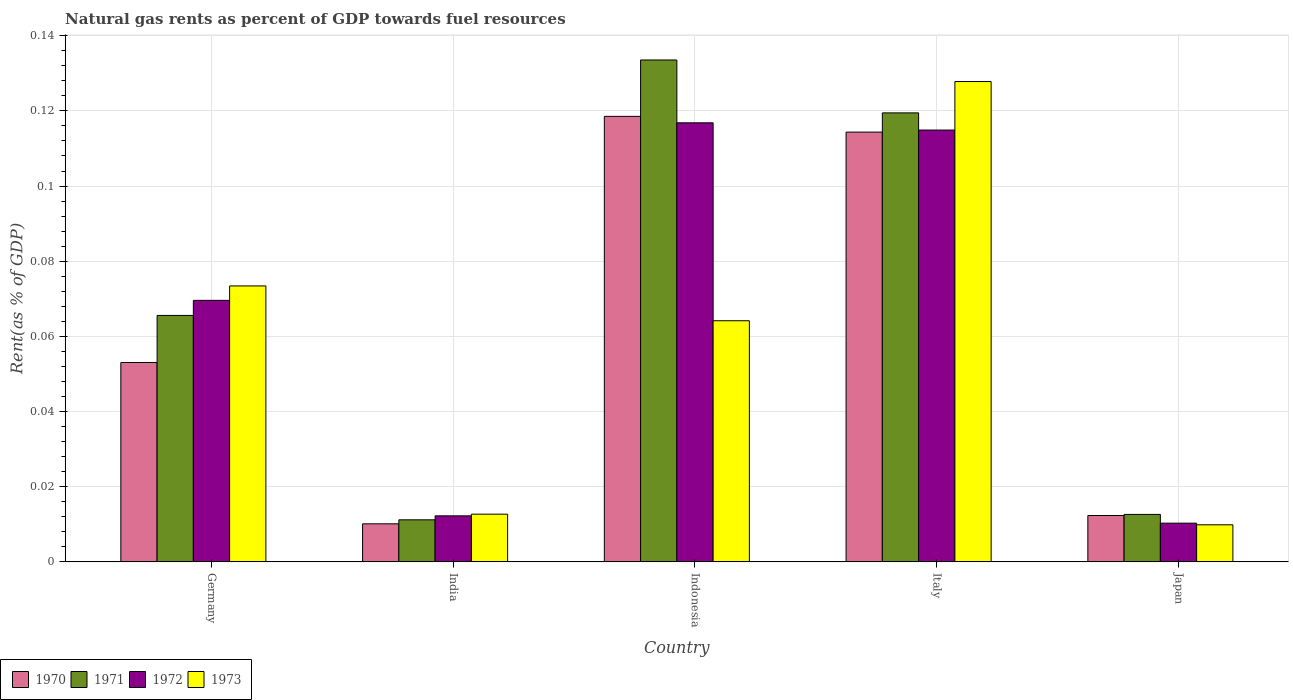How many groups of bars are there?
Provide a short and direct response. 5. Are the number of bars on each tick of the X-axis equal?
Offer a very short reply. Yes. How many bars are there on the 4th tick from the left?
Make the answer very short. 4. What is the matural gas rent in 1973 in Italy?
Offer a terse response. 0.13. Across all countries, what is the maximum matural gas rent in 1972?
Provide a succinct answer. 0.12. Across all countries, what is the minimum matural gas rent in 1971?
Provide a short and direct response. 0.01. In which country was the matural gas rent in 1970 minimum?
Your response must be concise. India. What is the total matural gas rent in 1971 in the graph?
Offer a terse response. 0.34. What is the difference between the matural gas rent in 1972 in India and that in Italy?
Ensure brevity in your answer.  -0.1. What is the difference between the matural gas rent in 1971 in India and the matural gas rent in 1970 in Germany?
Ensure brevity in your answer.  -0.04. What is the average matural gas rent in 1971 per country?
Ensure brevity in your answer.  0.07. What is the difference between the matural gas rent of/in 1971 and matural gas rent of/in 1973 in Italy?
Keep it short and to the point. -0.01. What is the ratio of the matural gas rent in 1972 in Italy to that in Japan?
Your answer should be very brief. 11.16. Is the difference between the matural gas rent in 1971 in Germany and India greater than the difference between the matural gas rent in 1973 in Germany and India?
Your response must be concise. No. What is the difference between the highest and the second highest matural gas rent in 1973?
Make the answer very short. 0.05. What is the difference between the highest and the lowest matural gas rent in 1970?
Your answer should be very brief. 0.11. In how many countries, is the matural gas rent in 1971 greater than the average matural gas rent in 1971 taken over all countries?
Ensure brevity in your answer.  2. How many bars are there?
Your response must be concise. 20. What is the difference between two consecutive major ticks on the Y-axis?
Give a very brief answer. 0.02. Are the values on the major ticks of Y-axis written in scientific E-notation?
Your answer should be compact. No. Does the graph contain any zero values?
Keep it short and to the point. No. Where does the legend appear in the graph?
Provide a succinct answer. Bottom left. How many legend labels are there?
Your answer should be very brief. 4. How are the legend labels stacked?
Keep it short and to the point. Horizontal. What is the title of the graph?
Offer a very short reply. Natural gas rents as percent of GDP towards fuel resources. Does "1974" appear as one of the legend labels in the graph?
Give a very brief answer. No. What is the label or title of the Y-axis?
Your response must be concise. Rent(as % of GDP). What is the Rent(as % of GDP) of 1970 in Germany?
Your answer should be compact. 0.05. What is the Rent(as % of GDP) of 1971 in Germany?
Your answer should be compact. 0.07. What is the Rent(as % of GDP) of 1972 in Germany?
Your response must be concise. 0.07. What is the Rent(as % of GDP) in 1973 in Germany?
Offer a very short reply. 0.07. What is the Rent(as % of GDP) in 1970 in India?
Your answer should be compact. 0.01. What is the Rent(as % of GDP) of 1971 in India?
Your answer should be very brief. 0.01. What is the Rent(as % of GDP) in 1972 in India?
Offer a very short reply. 0.01. What is the Rent(as % of GDP) of 1973 in India?
Offer a very short reply. 0.01. What is the Rent(as % of GDP) in 1970 in Indonesia?
Provide a succinct answer. 0.12. What is the Rent(as % of GDP) of 1971 in Indonesia?
Your answer should be compact. 0.13. What is the Rent(as % of GDP) of 1972 in Indonesia?
Your response must be concise. 0.12. What is the Rent(as % of GDP) of 1973 in Indonesia?
Give a very brief answer. 0.06. What is the Rent(as % of GDP) in 1970 in Italy?
Your response must be concise. 0.11. What is the Rent(as % of GDP) of 1971 in Italy?
Keep it short and to the point. 0.12. What is the Rent(as % of GDP) of 1972 in Italy?
Offer a terse response. 0.11. What is the Rent(as % of GDP) in 1973 in Italy?
Keep it short and to the point. 0.13. What is the Rent(as % of GDP) of 1970 in Japan?
Provide a short and direct response. 0.01. What is the Rent(as % of GDP) of 1971 in Japan?
Give a very brief answer. 0.01. What is the Rent(as % of GDP) in 1972 in Japan?
Offer a terse response. 0.01. What is the Rent(as % of GDP) of 1973 in Japan?
Provide a succinct answer. 0.01. Across all countries, what is the maximum Rent(as % of GDP) of 1970?
Provide a succinct answer. 0.12. Across all countries, what is the maximum Rent(as % of GDP) of 1971?
Keep it short and to the point. 0.13. Across all countries, what is the maximum Rent(as % of GDP) of 1972?
Ensure brevity in your answer.  0.12. Across all countries, what is the maximum Rent(as % of GDP) in 1973?
Ensure brevity in your answer.  0.13. Across all countries, what is the minimum Rent(as % of GDP) in 1970?
Give a very brief answer. 0.01. Across all countries, what is the minimum Rent(as % of GDP) in 1971?
Provide a succinct answer. 0.01. Across all countries, what is the minimum Rent(as % of GDP) in 1972?
Offer a terse response. 0.01. Across all countries, what is the minimum Rent(as % of GDP) of 1973?
Keep it short and to the point. 0.01. What is the total Rent(as % of GDP) of 1970 in the graph?
Your response must be concise. 0.31. What is the total Rent(as % of GDP) of 1971 in the graph?
Provide a short and direct response. 0.34. What is the total Rent(as % of GDP) in 1972 in the graph?
Your answer should be compact. 0.32. What is the total Rent(as % of GDP) in 1973 in the graph?
Keep it short and to the point. 0.29. What is the difference between the Rent(as % of GDP) of 1970 in Germany and that in India?
Your answer should be compact. 0.04. What is the difference between the Rent(as % of GDP) of 1971 in Germany and that in India?
Your answer should be very brief. 0.05. What is the difference between the Rent(as % of GDP) in 1972 in Germany and that in India?
Your response must be concise. 0.06. What is the difference between the Rent(as % of GDP) in 1973 in Germany and that in India?
Give a very brief answer. 0.06. What is the difference between the Rent(as % of GDP) in 1970 in Germany and that in Indonesia?
Offer a terse response. -0.07. What is the difference between the Rent(as % of GDP) in 1971 in Germany and that in Indonesia?
Your answer should be very brief. -0.07. What is the difference between the Rent(as % of GDP) in 1972 in Germany and that in Indonesia?
Offer a terse response. -0.05. What is the difference between the Rent(as % of GDP) of 1973 in Germany and that in Indonesia?
Your response must be concise. 0.01. What is the difference between the Rent(as % of GDP) of 1970 in Germany and that in Italy?
Make the answer very short. -0.06. What is the difference between the Rent(as % of GDP) in 1971 in Germany and that in Italy?
Your answer should be compact. -0.05. What is the difference between the Rent(as % of GDP) of 1972 in Germany and that in Italy?
Make the answer very short. -0.05. What is the difference between the Rent(as % of GDP) of 1973 in Germany and that in Italy?
Give a very brief answer. -0.05. What is the difference between the Rent(as % of GDP) in 1970 in Germany and that in Japan?
Ensure brevity in your answer.  0.04. What is the difference between the Rent(as % of GDP) in 1971 in Germany and that in Japan?
Make the answer very short. 0.05. What is the difference between the Rent(as % of GDP) of 1972 in Germany and that in Japan?
Your response must be concise. 0.06. What is the difference between the Rent(as % of GDP) of 1973 in Germany and that in Japan?
Ensure brevity in your answer.  0.06. What is the difference between the Rent(as % of GDP) in 1970 in India and that in Indonesia?
Ensure brevity in your answer.  -0.11. What is the difference between the Rent(as % of GDP) of 1971 in India and that in Indonesia?
Offer a terse response. -0.12. What is the difference between the Rent(as % of GDP) of 1972 in India and that in Indonesia?
Provide a succinct answer. -0.1. What is the difference between the Rent(as % of GDP) of 1973 in India and that in Indonesia?
Your answer should be compact. -0.05. What is the difference between the Rent(as % of GDP) of 1970 in India and that in Italy?
Give a very brief answer. -0.1. What is the difference between the Rent(as % of GDP) in 1971 in India and that in Italy?
Provide a short and direct response. -0.11. What is the difference between the Rent(as % of GDP) in 1972 in India and that in Italy?
Provide a succinct answer. -0.1. What is the difference between the Rent(as % of GDP) in 1973 in India and that in Italy?
Your answer should be very brief. -0.12. What is the difference between the Rent(as % of GDP) of 1970 in India and that in Japan?
Your answer should be very brief. -0. What is the difference between the Rent(as % of GDP) in 1971 in India and that in Japan?
Keep it short and to the point. -0. What is the difference between the Rent(as % of GDP) of 1972 in India and that in Japan?
Offer a terse response. 0. What is the difference between the Rent(as % of GDP) in 1973 in India and that in Japan?
Offer a terse response. 0. What is the difference between the Rent(as % of GDP) in 1970 in Indonesia and that in Italy?
Provide a short and direct response. 0. What is the difference between the Rent(as % of GDP) of 1971 in Indonesia and that in Italy?
Your response must be concise. 0.01. What is the difference between the Rent(as % of GDP) in 1972 in Indonesia and that in Italy?
Your response must be concise. 0. What is the difference between the Rent(as % of GDP) in 1973 in Indonesia and that in Italy?
Your response must be concise. -0.06. What is the difference between the Rent(as % of GDP) in 1970 in Indonesia and that in Japan?
Provide a succinct answer. 0.11. What is the difference between the Rent(as % of GDP) of 1971 in Indonesia and that in Japan?
Provide a succinct answer. 0.12. What is the difference between the Rent(as % of GDP) in 1972 in Indonesia and that in Japan?
Make the answer very short. 0.11. What is the difference between the Rent(as % of GDP) of 1973 in Indonesia and that in Japan?
Make the answer very short. 0.05. What is the difference between the Rent(as % of GDP) in 1970 in Italy and that in Japan?
Ensure brevity in your answer.  0.1. What is the difference between the Rent(as % of GDP) of 1971 in Italy and that in Japan?
Your answer should be compact. 0.11. What is the difference between the Rent(as % of GDP) of 1972 in Italy and that in Japan?
Offer a terse response. 0.1. What is the difference between the Rent(as % of GDP) of 1973 in Italy and that in Japan?
Make the answer very short. 0.12. What is the difference between the Rent(as % of GDP) of 1970 in Germany and the Rent(as % of GDP) of 1971 in India?
Ensure brevity in your answer.  0.04. What is the difference between the Rent(as % of GDP) of 1970 in Germany and the Rent(as % of GDP) of 1972 in India?
Your answer should be compact. 0.04. What is the difference between the Rent(as % of GDP) in 1970 in Germany and the Rent(as % of GDP) in 1973 in India?
Your answer should be very brief. 0.04. What is the difference between the Rent(as % of GDP) in 1971 in Germany and the Rent(as % of GDP) in 1972 in India?
Offer a terse response. 0.05. What is the difference between the Rent(as % of GDP) in 1971 in Germany and the Rent(as % of GDP) in 1973 in India?
Offer a very short reply. 0.05. What is the difference between the Rent(as % of GDP) of 1972 in Germany and the Rent(as % of GDP) of 1973 in India?
Offer a very short reply. 0.06. What is the difference between the Rent(as % of GDP) of 1970 in Germany and the Rent(as % of GDP) of 1971 in Indonesia?
Offer a terse response. -0.08. What is the difference between the Rent(as % of GDP) of 1970 in Germany and the Rent(as % of GDP) of 1972 in Indonesia?
Offer a terse response. -0.06. What is the difference between the Rent(as % of GDP) in 1970 in Germany and the Rent(as % of GDP) in 1973 in Indonesia?
Give a very brief answer. -0.01. What is the difference between the Rent(as % of GDP) of 1971 in Germany and the Rent(as % of GDP) of 1972 in Indonesia?
Offer a terse response. -0.05. What is the difference between the Rent(as % of GDP) of 1971 in Germany and the Rent(as % of GDP) of 1973 in Indonesia?
Offer a very short reply. 0. What is the difference between the Rent(as % of GDP) of 1972 in Germany and the Rent(as % of GDP) of 1973 in Indonesia?
Provide a short and direct response. 0.01. What is the difference between the Rent(as % of GDP) in 1970 in Germany and the Rent(as % of GDP) in 1971 in Italy?
Your answer should be compact. -0.07. What is the difference between the Rent(as % of GDP) of 1970 in Germany and the Rent(as % of GDP) of 1972 in Italy?
Give a very brief answer. -0.06. What is the difference between the Rent(as % of GDP) of 1970 in Germany and the Rent(as % of GDP) of 1973 in Italy?
Your response must be concise. -0.07. What is the difference between the Rent(as % of GDP) of 1971 in Germany and the Rent(as % of GDP) of 1972 in Italy?
Ensure brevity in your answer.  -0.05. What is the difference between the Rent(as % of GDP) in 1971 in Germany and the Rent(as % of GDP) in 1973 in Italy?
Your answer should be compact. -0.06. What is the difference between the Rent(as % of GDP) in 1972 in Germany and the Rent(as % of GDP) in 1973 in Italy?
Your response must be concise. -0.06. What is the difference between the Rent(as % of GDP) in 1970 in Germany and the Rent(as % of GDP) in 1971 in Japan?
Give a very brief answer. 0.04. What is the difference between the Rent(as % of GDP) in 1970 in Germany and the Rent(as % of GDP) in 1972 in Japan?
Your answer should be very brief. 0.04. What is the difference between the Rent(as % of GDP) in 1970 in Germany and the Rent(as % of GDP) in 1973 in Japan?
Your response must be concise. 0.04. What is the difference between the Rent(as % of GDP) in 1971 in Germany and the Rent(as % of GDP) in 1972 in Japan?
Provide a succinct answer. 0.06. What is the difference between the Rent(as % of GDP) of 1971 in Germany and the Rent(as % of GDP) of 1973 in Japan?
Your answer should be very brief. 0.06. What is the difference between the Rent(as % of GDP) of 1972 in Germany and the Rent(as % of GDP) of 1973 in Japan?
Give a very brief answer. 0.06. What is the difference between the Rent(as % of GDP) in 1970 in India and the Rent(as % of GDP) in 1971 in Indonesia?
Your answer should be compact. -0.12. What is the difference between the Rent(as % of GDP) of 1970 in India and the Rent(as % of GDP) of 1972 in Indonesia?
Ensure brevity in your answer.  -0.11. What is the difference between the Rent(as % of GDP) of 1970 in India and the Rent(as % of GDP) of 1973 in Indonesia?
Ensure brevity in your answer.  -0.05. What is the difference between the Rent(as % of GDP) of 1971 in India and the Rent(as % of GDP) of 1972 in Indonesia?
Offer a terse response. -0.11. What is the difference between the Rent(as % of GDP) of 1971 in India and the Rent(as % of GDP) of 1973 in Indonesia?
Your response must be concise. -0.05. What is the difference between the Rent(as % of GDP) of 1972 in India and the Rent(as % of GDP) of 1973 in Indonesia?
Your answer should be compact. -0.05. What is the difference between the Rent(as % of GDP) of 1970 in India and the Rent(as % of GDP) of 1971 in Italy?
Keep it short and to the point. -0.11. What is the difference between the Rent(as % of GDP) of 1970 in India and the Rent(as % of GDP) of 1972 in Italy?
Provide a succinct answer. -0.1. What is the difference between the Rent(as % of GDP) of 1970 in India and the Rent(as % of GDP) of 1973 in Italy?
Ensure brevity in your answer.  -0.12. What is the difference between the Rent(as % of GDP) of 1971 in India and the Rent(as % of GDP) of 1972 in Italy?
Provide a succinct answer. -0.1. What is the difference between the Rent(as % of GDP) of 1971 in India and the Rent(as % of GDP) of 1973 in Italy?
Keep it short and to the point. -0.12. What is the difference between the Rent(as % of GDP) of 1972 in India and the Rent(as % of GDP) of 1973 in Italy?
Give a very brief answer. -0.12. What is the difference between the Rent(as % of GDP) in 1970 in India and the Rent(as % of GDP) in 1971 in Japan?
Provide a short and direct response. -0. What is the difference between the Rent(as % of GDP) in 1970 in India and the Rent(as % of GDP) in 1972 in Japan?
Provide a short and direct response. -0. What is the difference between the Rent(as % of GDP) in 1971 in India and the Rent(as % of GDP) in 1972 in Japan?
Keep it short and to the point. 0. What is the difference between the Rent(as % of GDP) of 1971 in India and the Rent(as % of GDP) of 1973 in Japan?
Offer a terse response. 0. What is the difference between the Rent(as % of GDP) in 1972 in India and the Rent(as % of GDP) in 1973 in Japan?
Your answer should be very brief. 0. What is the difference between the Rent(as % of GDP) in 1970 in Indonesia and the Rent(as % of GDP) in 1971 in Italy?
Your response must be concise. -0. What is the difference between the Rent(as % of GDP) in 1970 in Indonesia and the Rent(as % of GDP) in 1972 in Italy?
Make the answer very short. 0. What is the difference between the Rent(as % of GDP) in 1970 in Indonesia and the Rent(as % of GDP) in 1973 in Italy?
Provide a succinct answer. -0.01. What is the difference between the Rent(as % of GDP) in 1971 in Indonesia and the Rent(as % of GDP) in 1972 in Italy?
Your answer should be compact. 0.02. What is the difference between the Rent(as % of GDP) in 1971 in Indonesia and the Rent(as % of GDP) in 1973 in Italy?
Offer a terse response. 0.01. What is the difference between the Rent(as % of GDP) of 1972 in Indonesia and the Rent(as % of GDP) of 1973 in Italy?
Your answer should be very brief. -0.01. What is the difference between the Rent(as % of GDP) in 1970 in Indonesia and the Rent(as % of GDP) in 1971 in Japan?
Ensure brevity in your answer.  0.11. What is the difference between the Rent(as % of GDP) of 1970 in Indonesia and the Rent(as % of GDP) of 1972 in Japan?
Your response must be concise. 0.11. What is the difference between the Rent(as % of GDP) in 1970 in Indonesia and the Rent(as % of GDP) in 1973 in Japan?
Ensure brevity in your answer.  0.11. What is the difference between the Rent(as % of GDP) of 1971 in Indonesia and the Rent(as % of GDP) of 1972 in Japan?
Give a very brief answer. 0.12. What is the difference between the Rent(as % of GDP) of 1971 in Indonesia and the Rent(as % of GDP) of 1973 in Japan?
Keep it short and to the point. 0.12. What is the difference between the Rent(as % of GDP) of 1972 in Indonesia and the Rent(as % of GDP) of 1973 in Japan?
Offer a very short reply. 0.11. What is the difference between the Rent(as % of GDP) in 1970 in Italy and the Rent(as % of GDP) in 1971 in Japan?
Provide a succinct answer. 0.1. What is the difference between the Rent(as % of GDP) in 1970 in Italy and the Rent(as % of GDP) in 1972 in Japan?
Provide a short and direct response. 0.1. What is the difference between the Rent(as % of GDP) of 1970 in Italy and the Rent(as % of GDP) of 1973 in Japan?
Provide a succinct answer. 0.1. What is the difference between the Rent(as % of GDP) of 1971 in Italy and the Rent(as % of GDP) of 1972 in Japan?
Your response must be concise. 0.11. What is the difference between the Rent(as % of GDP) in 1971 in Italy and the Rent(as % of GDP) in 1973 in Japan?
Provide a succinct answer. 0.11. What is the difference between the Rent(as % of GDP) in 1972 in Italy and the Rent(as % of GDP) in 1973 in Japan?
Provide a short and direct response. 0.1. What is the average Rent(as % of GDP) of 1970 per country?
Your answer should be very brief. 0.06. What is the average Rent(as % of GDP) of 1971 per country?
Provide a short and direct response. 0.07. What is the average Rent(as % of GDP) of 1972 per country?
Offer a very short reply. 0.06. What is the average Rent(as % of GDP) of 1973 per country?
Give a very brief answer. 0.06. What is the difference between the Rent(as % of GDP) of 1970 and Rent(as % of GDP) of 1971 in Germany?
Make the answer very short. -0.01. What is the difference between the Rent(as % of GDP) in 1970 and Rent(as % of GDP) in 1972 in Germany?
Provide a short and direct response. -0.02. What is the difference between the Rent(as % of GDP) of 1970 and Rent(as % of GDP) of 1973 in Germany?
Give a very brief answer. -0.02. What is the difference between the Rent(as % of GDP) in 1971 and Rent(as % of GDP) in 1972 in Germany?
Your answer should be compact. -0. What is the difference between the Rent(as % of GDP) of 1971 and Rent(as % of GDP) of 1973 in Germany?
Your answer should be very brief. -0.01. What is the difference between the Rent(as % of GDP) in 1972 and Rent(as % of GDP) in 1973 in Germany?
Provide a short and direct response. -0. What is the difference between the Rent(as % of GDP) in 1970 and Rent(as % of GDP) in 1971 in India?
Keep it short and to the point. -0. What is the difference between the Rent(as % of GDP) in 1970 and Rent(as % of GDP) in 1972 in India?
Provide a succinct answer. -0. What is the difference between the Rent(as % of GDP) of 1970 and Rent(as % of GDP) of 1973 in India?
Your answer should be very brief. -0. What is the difference between the Rent(as % of GDP) of 1971 and Rent(as % of GDP) of 1972 in India?
Keep it short and to the point. -0. What is the difference between the Rent(as % of GDP) in 1971 and Rent(as % of GDP) in 1973 in India?
Provide a short and direct response. -0. What is the difference between the Rent(as % of GDP) of 1972 and Rent(as % of GDP) of 1973 in India?
Ensure brevity in your answer.  -0. What is the difference between the Rent(as % of GDP) in 1970 and Rent(as % of GDP) in 1971 in Indonesia?
Your response must be concise. -0.01. What is the difference between the Rent(as % of GDP) of 1970 and Rent(as % of GDP) of 1972 in Indonesia?
Keep it short and to the point. 0. What is the difference between the Rent(as % of GDP) of 1970 and Rent(as % of GDP) of 1973 in Indonesia?
Give a very brief answer. 0.05. What is the difference between the Rent(as % of GDP) in 1971 and Rent(as % of GDP) in 1972 in Indonesia?
Offer a very short reply. 0.02. What is the difference between the Rent(as % of GDP) of 1971 and Rent(as % of GDP) of 1973 in Indonesia?
Provide a succinct answer. 0.07. What is the difference between the Rent(as % of GDP) of 1972 and Rent(as % of GDP) of 1973 in Indonesia?
Provide a short and direct response. 0.05. What is the difference between the Rent(as % of GDP) of 1970 and Rent(as % of GDP) of 1971 in Italy?
Provide a succinct answer. -0.01. What is the difference between the Rent(as % of GDP) of 1970 and Rent(as % of GDP) of 1972 in Italy?
Provide a short and direct response. -0. What is the difference between the Rent(as % of GDP) of 1970 and Rent(as % of GDP) of 1973 in Italy?
Provide a short and direct response. -0.01. What is the difference between the Rent(as % of GDP) in 1971 and Rent(as % of GDP) in 1972 in Italy?
Your answer should be very brief. 0. What is the difference between the Rent(as % of GDP) of 1971 and Rent(as % of GDP) of 1973 in Italy?
Your answer should be compact. -0.01. What is the difference between the Rent(as % of GDP) of 1972 and Rent(as % of GDP) of 1973 in Italy?
Your answer should be compact. -0.01. What is the difference between the Rent(as % of GDP) of 1970 and Rent(as % of GDP) of 1971 in Japan?
Provide a succinct answer. -0. What is the difference between the Rent(as % of GDP) in 1970 and Rent(as % of GDP) in 1972 in Japan?
Make the answer very short. 0. What is the difference between the Rent(as % of GDP) in 1970 and Rent(as % of GDP) in 1973 in Japan?
Your answer should be compact. 0. What is the difference between the Rent(as % of GDP) of 1971 and Rent(as % of GDP) of 1972 in Japan?
Your answer should be very brief. 0. What is the difference between the Rent(as % of GDP) of 1971 and Rent(as % of GDP) of 1973 in Japan?
Provide a short and direct response. 0. What is the ratio of the Rent(as % of GDP) in 1970 in Germany to that in India?
Your response must be concise. 5.24. What is the ratio of the Rent(as % of GDP) of 1971 in Germany to that in India?
Give a very brief answer. 5.86. What is the ratio of the Rent(as % of GDP) in 1972 in Germany to that in India?
Make the answer very short. 5.68. What is the ratio of the Rent(as % of GDP) of 1973 in Germany to that in India?
Provide a succinct answer. 5.79. What is the ratio of the Rent(as % of GDP) of 1970 in Germany to that in Indonesia?
Offer a terse response. 0.45. What is the ratio of the Rent(as % of GDP) of 1971 in Germany to that in Indonesia?
Your response must be concise. 0.49. What is the ratio of the Rent(as % of GDP) of 1972 in Germany to that in Indonesia?
Make the answer very short. 0.6. What is the ratio of the Rent(as % of GDP) of 1973 in Germany to that in Indonesia?
Provide a succinct answer. 1.14. What is the ratio of the Rent(as % of GDP) of 1970 in Germany to that in Italy?
Provide a short and direct response. 0.46. What is the ratio of the Rent(as % of GDP) of 1971 in Germany to that in Italy?
Give a very brief answer. 0.55. What is the ratio of the Rent(as % of GDP) in 1972 in Germany to that in Italy?
Make the answer very short. 0.61. What is the ratio of the Rent(as % of GDP) in 1973 in Germany to that in Italy?
Your answer should be compact. 0.57. What is the ratio of the Rent(as % of GDP) in 1970 in Germany to that in Japan?
Keep it short and to the point. 4.3. What is the ratio of the Rent(as % of GDP) of 1971 in Germany to that in Japan?
Offer a terse response. 5.19. What is the ratio of the Rent(as % of GDP) in 1972 in Germany to that in Japan?
Your answer should be compact. 6.76. What is the ratio of the Rent(as % of GDP) of 1973 in Germany to that in Japan?
Keep it short and to the point. 7.44. What is the ratio of the Rent(as % of GDP) of 1970 in India to that in Indonesia?
Your answer should be very brief. 0.09. What is the ratio of the Rent(as % of GDP) of 1971 in India to that in Indonesia?
Your answer should be compact. 0.08. What is the ratio of the Rent(as % of GDP) in 1972 in India to that in Indonesia?
Keep it short and to the point. 0.1. What is the ratio of the Rent(as % of GDP) in 1973 in India to that in Indonesia?
Provide a succinct answer. 0.2. What is the ratio of the Rent(as % of GDP) of 1970 in India to that in Italy?
Offer a very short reply. 0.09. What is the ratio of the Rent(as % of GDP) of 1971 in India to that in Italy?
Offer a very short reply. 0.09. What is the ratio of the Rent(as % of GDP) of 1972 in India to that in Italy?
Your answer should be compact. 0.11. What is the ratio of the Rent(as % of GDP) in 1973 in India to that in Italy?
Your answer should be very brief. 0.1. What is the ratio of the Rent(as % of GDP) of 1970 in India to that in Japan?
Give a very brief answer. 0.82. What is the ratio of the Rent(as % of GDP) in 1971 in India to that in Japan?
Provide a succinct answer. 0.89. What is the ratio of the Rent(as % of GDP) in 1972 in India to that in Japan?
Your answer should be compact. 1.19. What is the ratio of the Rent(as % of GDP) of 1973 in India to that in Japan?
Give a very brief answer. 1.29. What is the ratio of the Rent(as % of GDP) of 1970 in Indonesia to that in Italy?
Provide a succinct answer. 1.04. What is the ratio of the Rent(as % of GDP) in 1971 in Indonesia to that in Italy?
Make the answer very short. 1.12. What is the ratio of the Rent(as % of GDP) of 1972 in Indonesia to that in Italy?
Make the answer very short. 1.02. What is the ratio of the Rent(as % of GDP) in 1973 in Indonesia to that in Italy?
Provide a succinct answer. 0.5. What is the ratio of the Rent(as % of GDP) in 1970 in Indonesia to that in Japan?
Provide a succinct answer. 9.61. What is the ratio of the Rent(as % of GDP) of 1971 in Indonesia to that in Japan?
Provide a short and direct response. 10.58. What is the ratio of the Rent(as % of GDP) in 1972 in Indonesia to that in Japan?
Keep it short and to the point. 11.34. What is the ratio of the Rent(as % of GDP) in 1973 in Indonesia to that in Japan?
Your answer should be very brief. 6.5. What is the ratio of the Rent(as % of GDP) in 1970 in Italy to that in Japan?
Your answer should be compact. 9.27. What is the ratio of the Rent(as % of GDP) of 1971 in Italy to that in Japan?
Ensure brevity in your answer.  9.46. What is the ratio of the Rent(as % of GDP) in 1972 in Italy to that in Japan?
Provide a short and direct response. 11.16. What is the ratio of the Rent(as % of GDP) in 1973 in Italy to that in Japan?
Give a very brief answer. 12.96. What is the difference between the highest and the second highest Rent(as % of GDP) in 1970?
Your answer should be very brief. 0. What is the difference between the highest and the second highest Rent(as % of GDP) of 1971?
Your answer should be very brief. 0.01. What is the difference between the highest and the second highest Rent(as % of GDP) of 1972?
Offer a very short reply. 0. What is the difference between the highest and the second highest Rent(as % of GDP) in 1973?
Provide a short and direct response. 0.05. What is the difference between the highest and the lowest Rent(as % of GDP) in 1970?
Keep it short and to the point. 0.11. What is the difference between the highest and the lowest Rent(as % of GDP) in 1971?
Offer a terse response. 0.12. What is the difference between the highest and the lowest Rent(as % of GDP) of 1972?
Your answer should be compact. 0.11. What is the difference between the highest and the lowest Rent(as % of GDP) in 1973?
Provide a succinct answer. 0.12. 